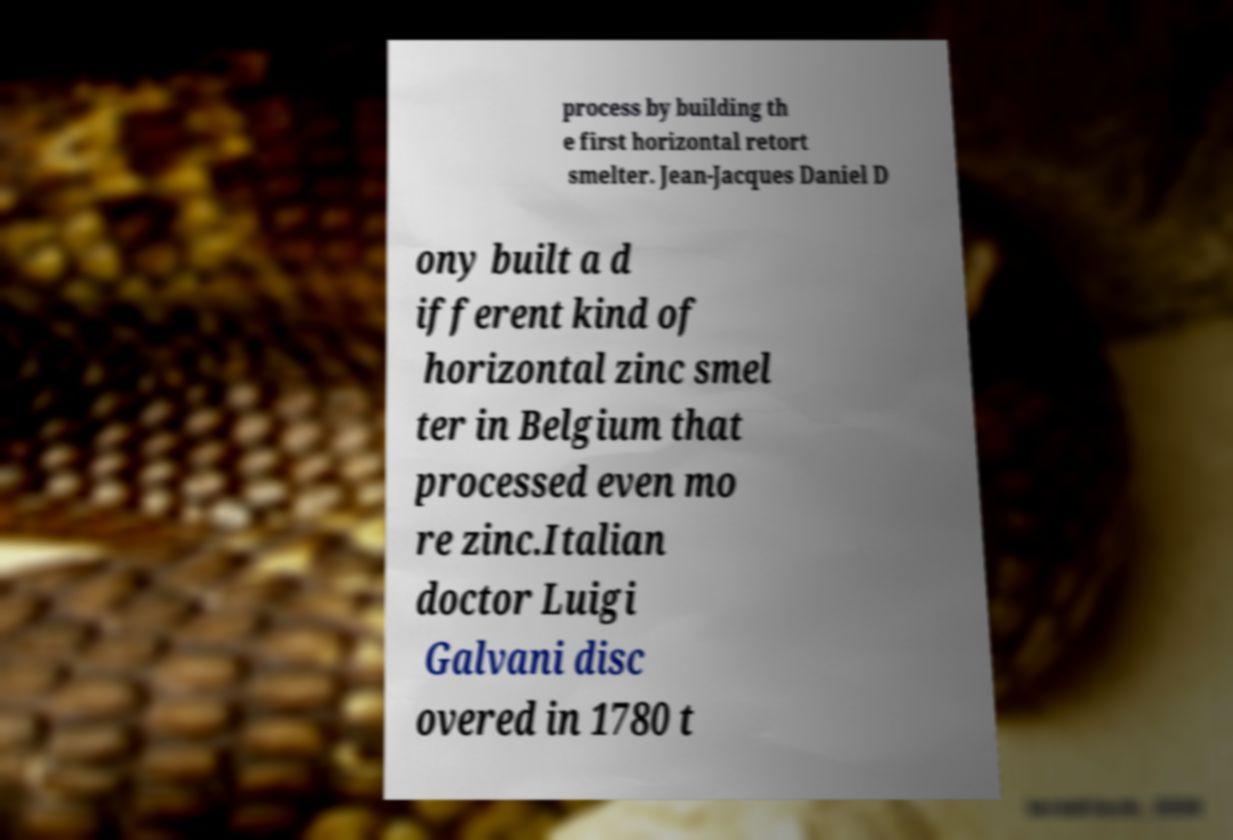Can you accurately transcribe the text from the provided image for me? process by building th e first horizontal retort smelter. Jean-Jacques Daniel D ony built a d ifferent kind of horizontal zinc smel ter in Belgium that processed even mo re zinc.Italian doctor Luigi Galvani disc overed in 1780 t 